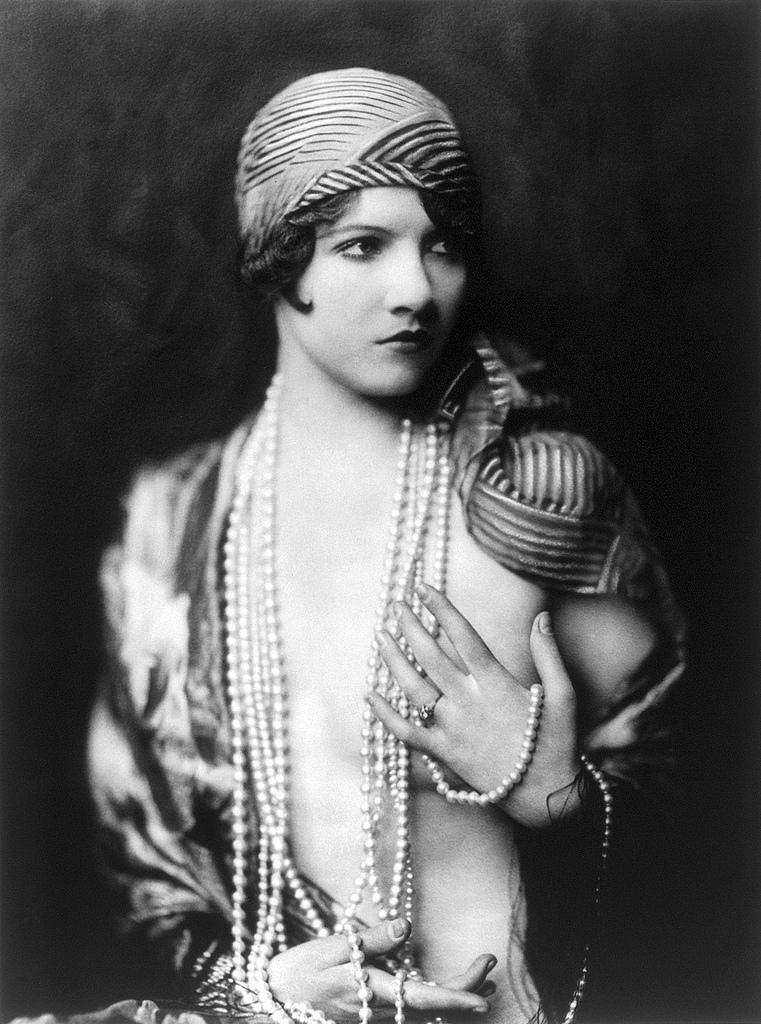Please provide a concise description of this image. This is a black and white picture. In this picture we can see a person wearing pearl jewellery and giving a pose. 